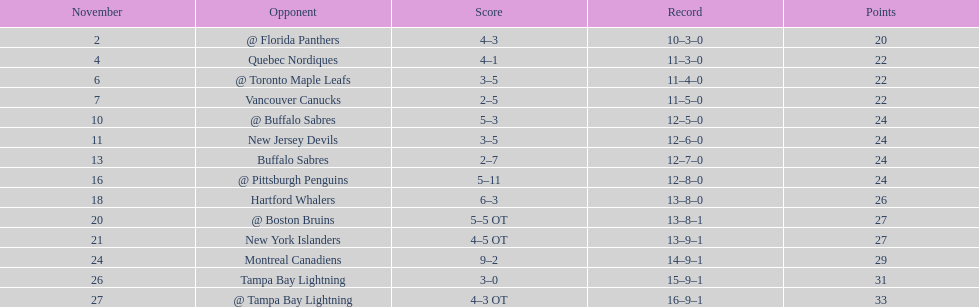In the 1993-1994 season, which was the only team in the atlantic division to secure less points than the philadelphia flyers? Tampa Bay Lightning. 